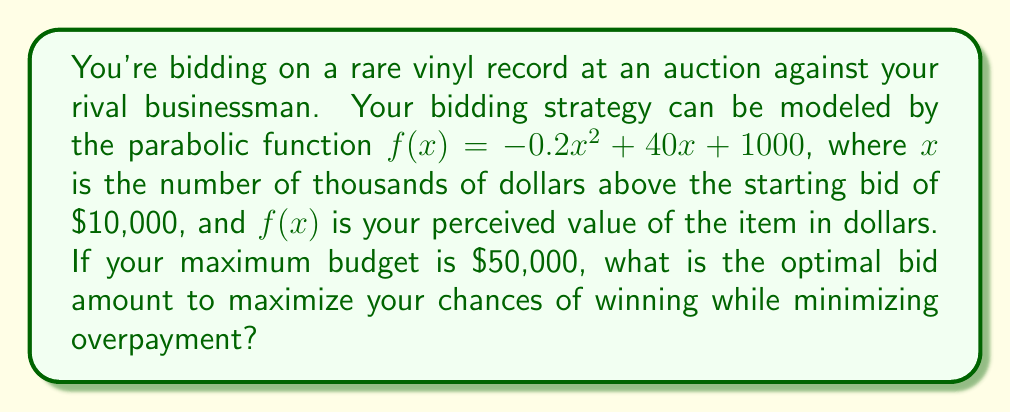Help me with this question. 1) First, we need to find the vertex of the parabola, which represents the maximum value:
   The vertex formula for $f(x) = ax^2 + bx + c$ is $x = -\frac{b}{2a}$
   Here, $a = -0.2$, $b = 40$
   $x = -\frac{40}{2(-0.2)} = 100$

2) However, our budget constraint is $50,000, which is $40,000 above the starting bid.
   So, we need to find the maximum of $f(x)$ in the interval $[0, 40]$

3) Since the vertex is beyond our budget, the maximum value within our range will be at $x = 40$

4) Calculate $f(40)$:
   $f(40) = -0.2(40)^2 + 40(40) + 1000$
   $= -320 + 1600 + 1000 = 2280$

5) This means at a bid of $50,000 ($40,000 above starting), your perceived value is $2,280

6) To find the optimal bid, we need to solve:
   $-0.2x^2 + 40x + 1000 = 50000$
   $-0.2x^2 + 40x - 49000 = 0$

7) Using the quadratic formula: $x = \frac{-b \pm \sqrt{b^2 - 4ac}}{2a}$
   $x = \frac{-40 \pm \sqrt{40^2 - 4(-0.2)(-49000)}}{2(-0.2)}$
   $x \approx 38.23$ or $x \approx 261.77$

8) Since $261.77$ is outside our budget, we take $38.23$

9) The optimal bid is therefore $10,000 + 38,230 = $48,230$
Answer: $48,230 